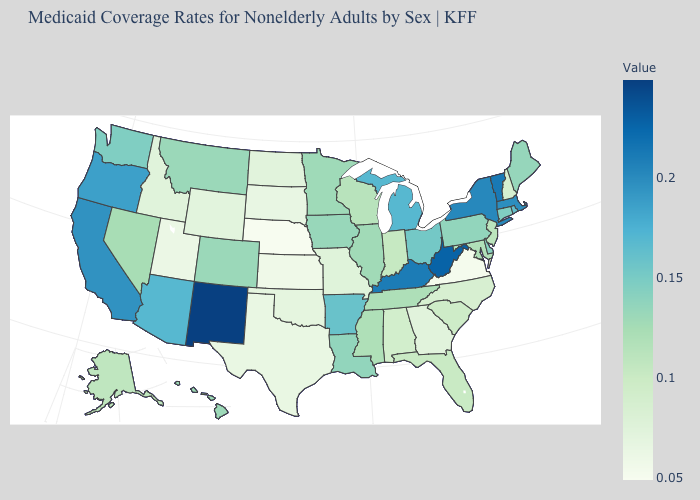Does Connecticut have a lower value than Nevada?
Quick response, please. No. Does Nebraska have the lowest value in the USA?
Give a very brief answer. Yes. Which states have the lowest value in the USA?
Quick response, please. Nebraska. Among the states that border Montana , which have the lowest value?
Keep it brief. South Dakota. Among the states that border New Jersey , does New York have the highest value?
Be succinct. Yes. 